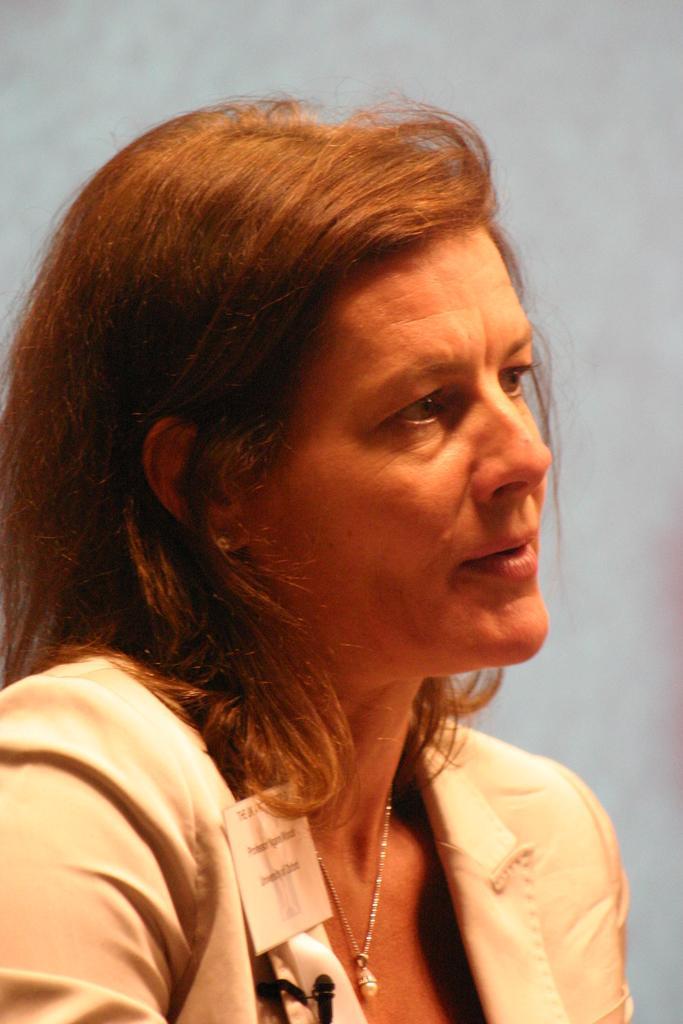Please provide a concise description of this image. This woman is looking right side of the image. Background it is blur. 